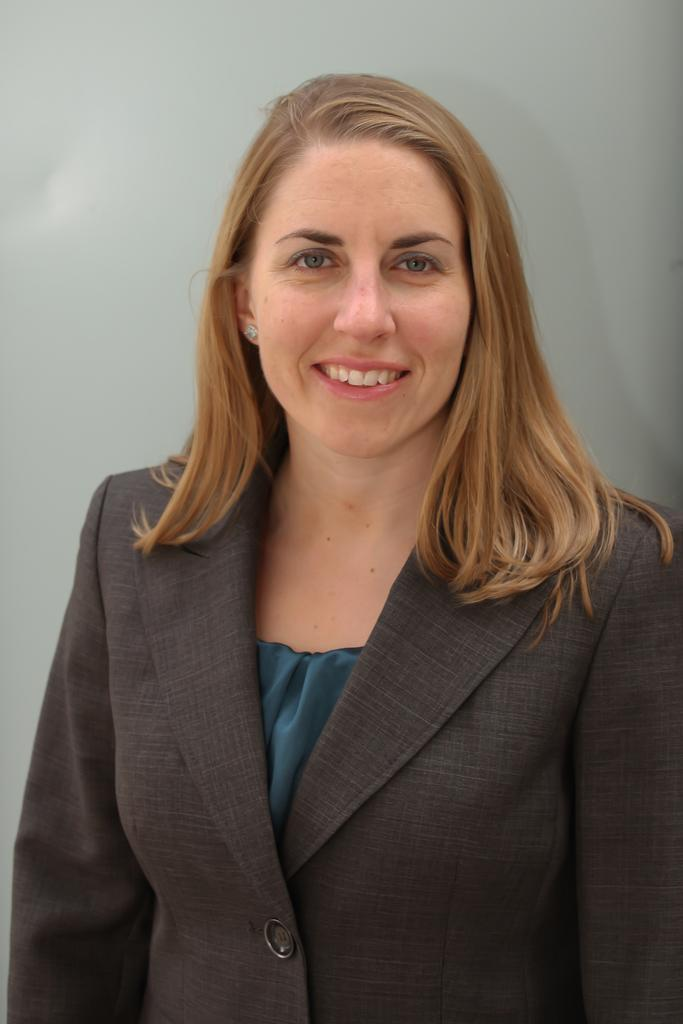Who is present in the image? There is a woman in the image. What expression does the woman have? The woman is smiling. What type of clothing is the woman wearing? The woman is wearing a formal dress. Where is the nest located in the image? There is no nest present in the image. What type of music can be heard in the background of the image? There is no music present in the image. 